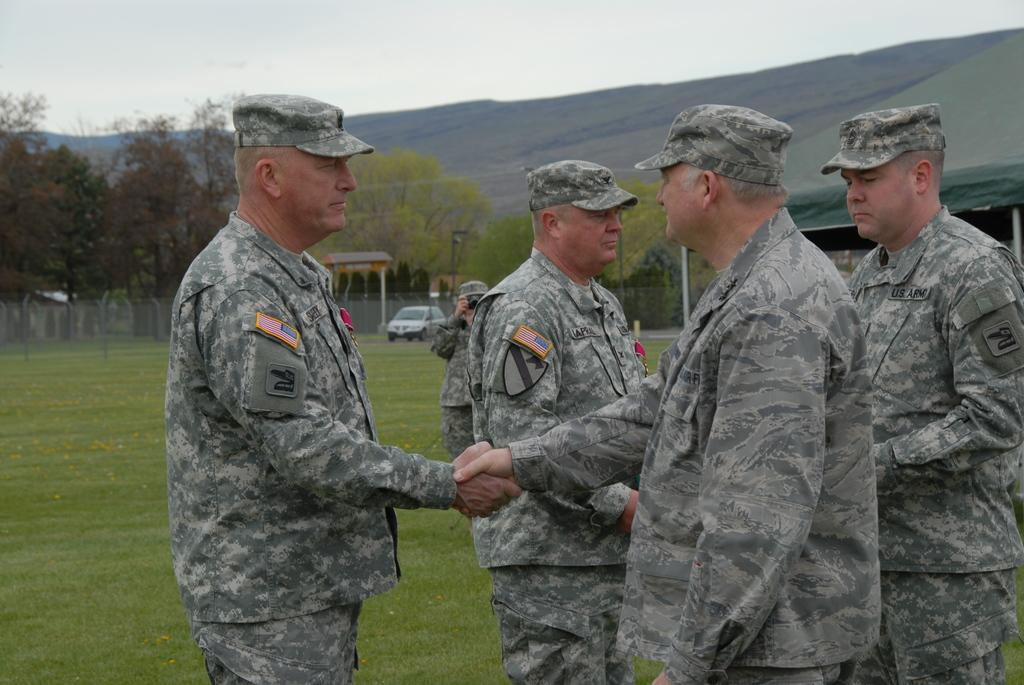How many people are in the image? There are people in the image, but the exact number is not specified. What is the terrain like in the image? The land is covered with grass in the image. What structures can be seen in the background of the image? There is a tent, trees, a pole, a vehicle, a mesh, and a hill in the background of the image. What part of the natural environment is visible in the image? The sky is visible in the background of the image. What type of beam is holding up the sheet in the image? There is no beam or sheet present in the image. How many folds are visible in the sheet in the image? There is no sheet present in the image, so it is not possible to determine the number of folds. 